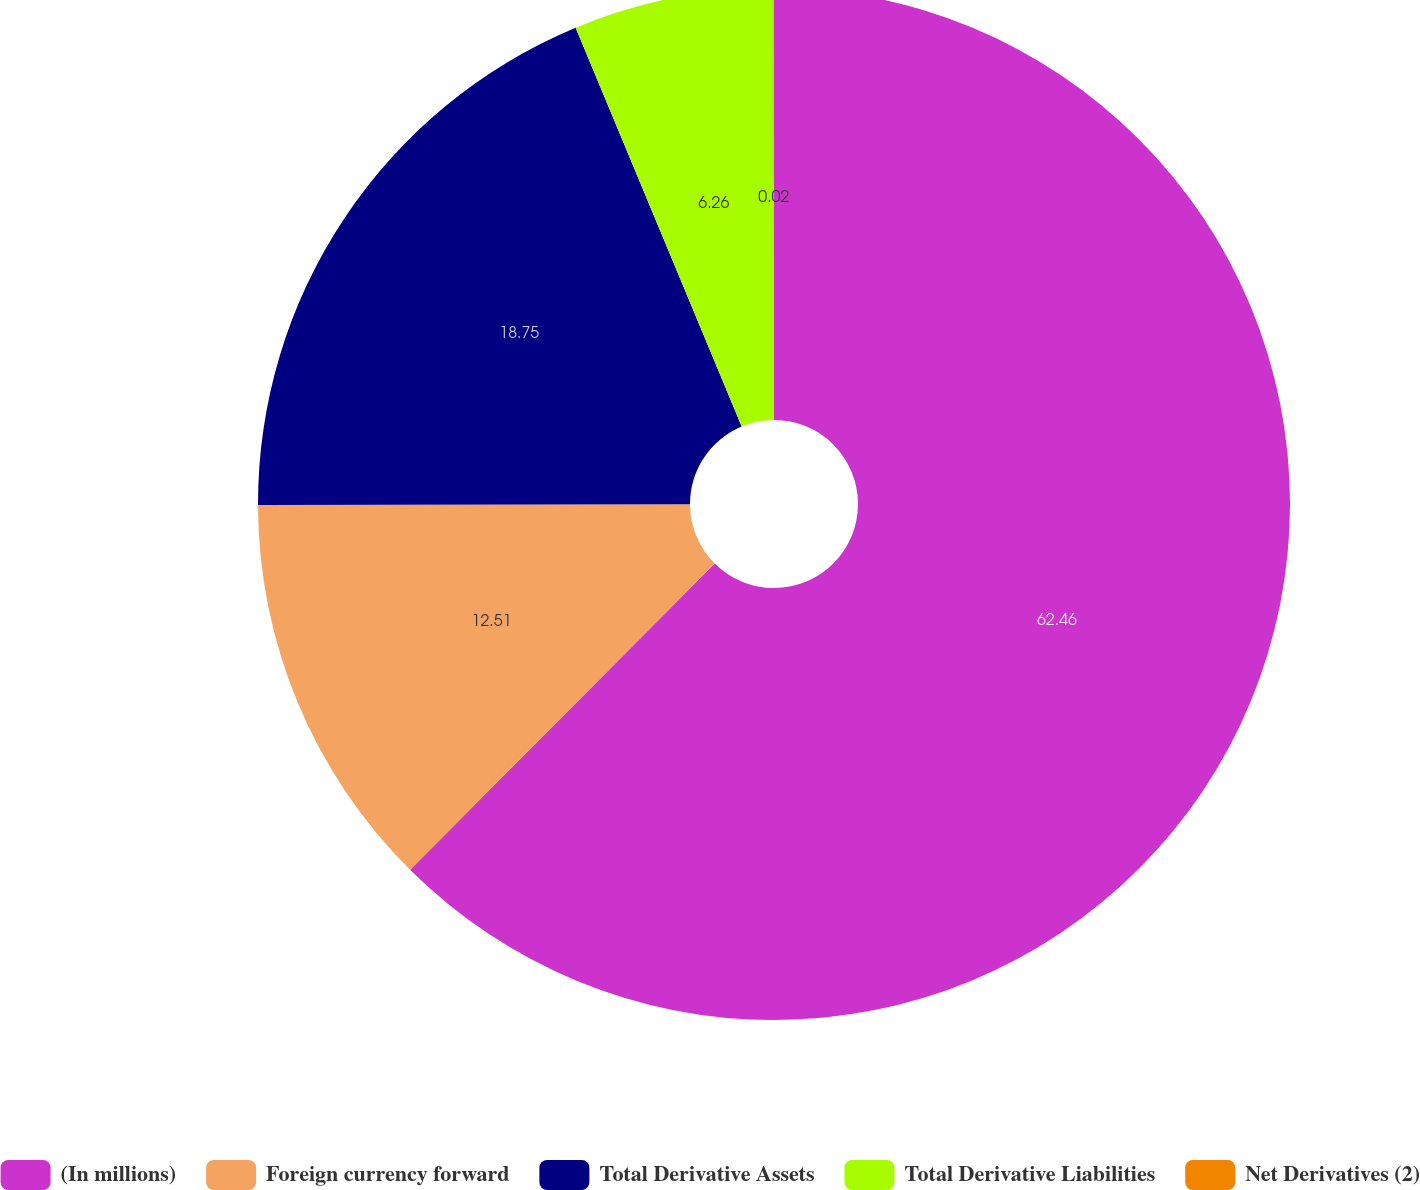Convert chart. <chart><loc_0><loc_0><loc_500><loc_500><pie_chart><fcel>(In millions)<fcel>Foreign currency forward<fcel>Total Derivative Assets<fcel>Total Derivative Liabilities<fcel>Net Derivatives (2)<nl><fcel>62.46%<fcel>12.51%<fcel>18.75%<fcel>6.26%<fcel>0.02%<nl></chart> 